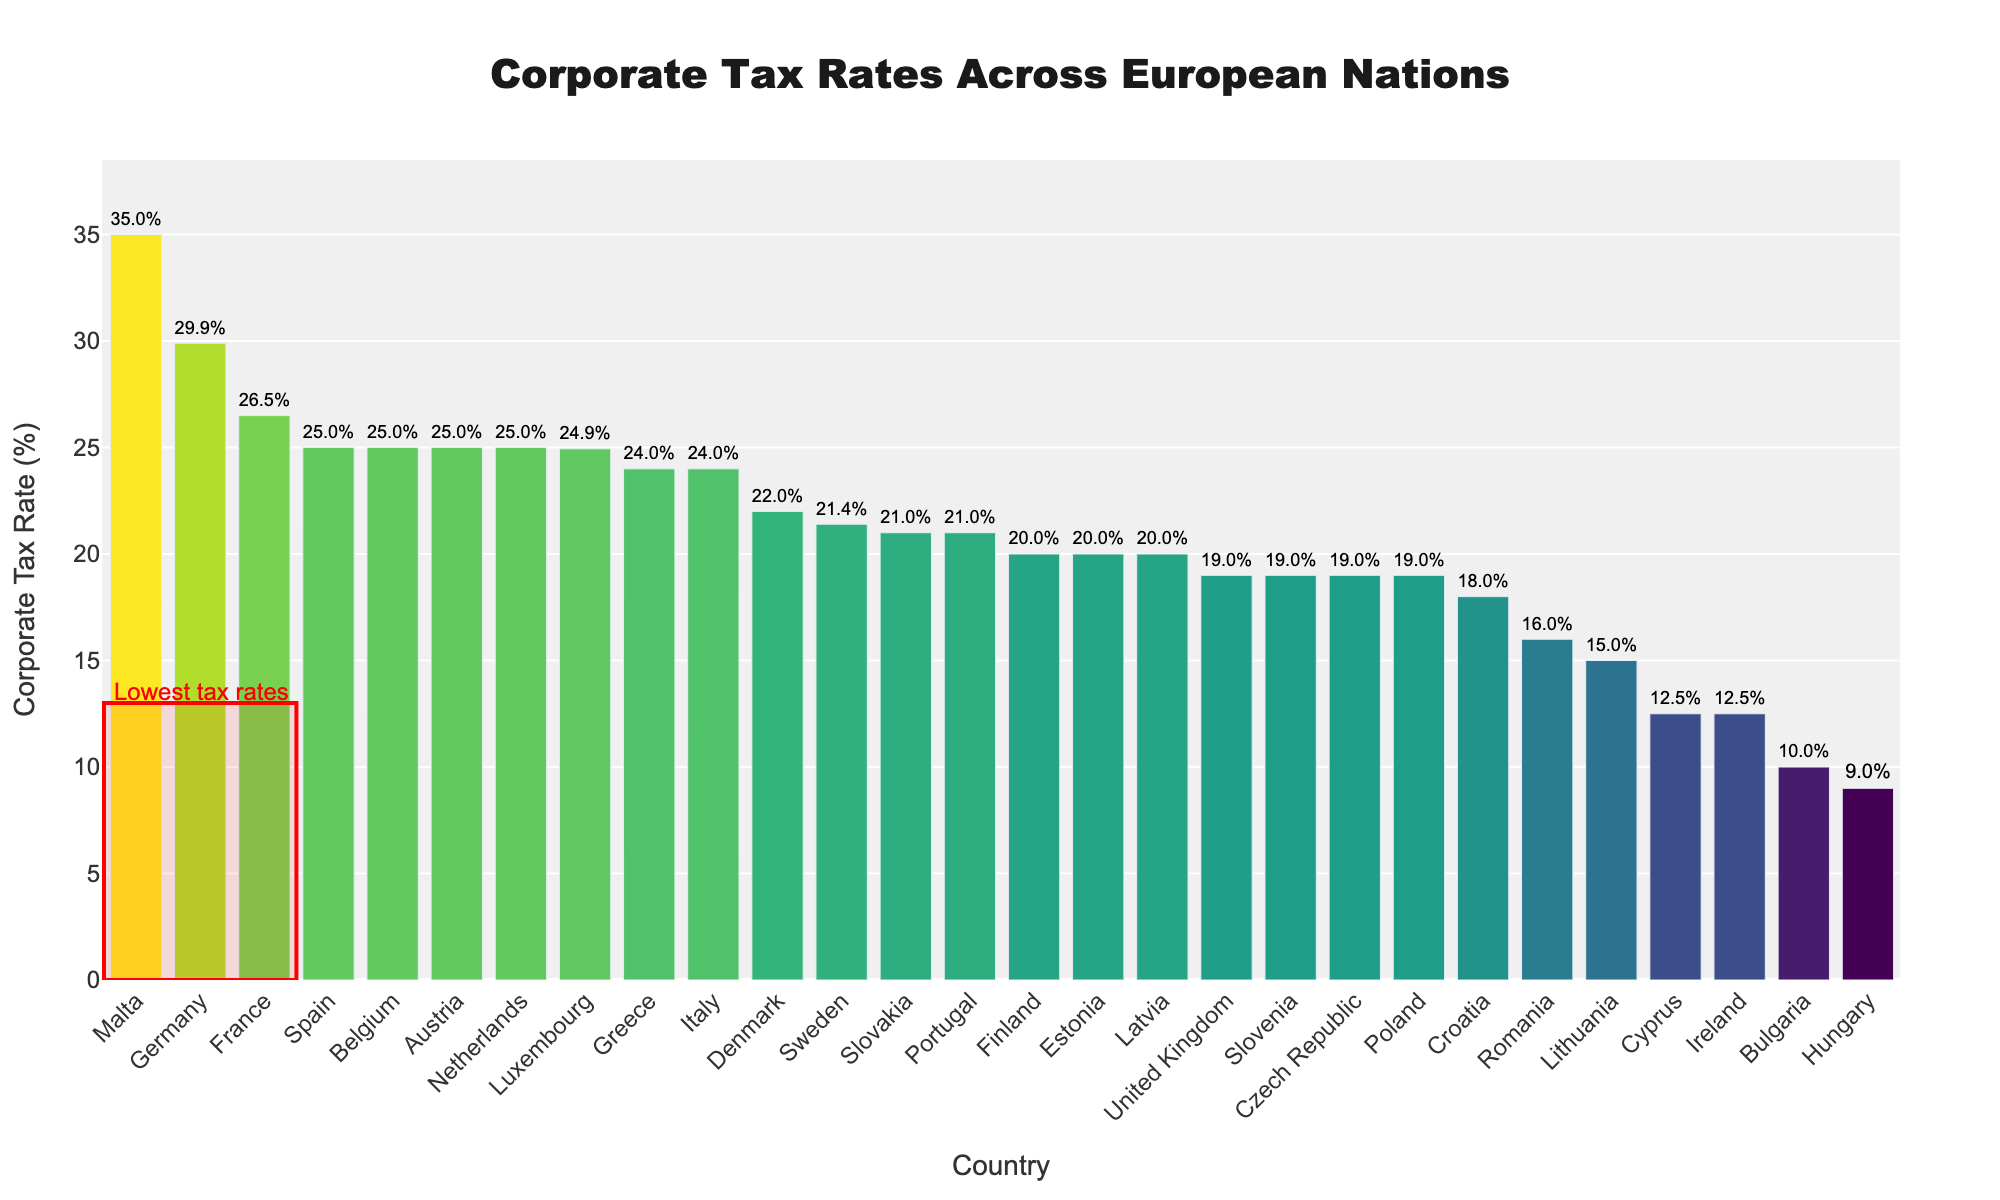Which country has the highest corporate tax rate? The highest bar in the chart represents the country with the highest tax rate. Malta has the highest corporate tax rate at 35%.
Answer: Malta Which countries have corporate tax rates below 10%? Visually identify the bars within the highlighted section labeled "Lowest tax rates". Hungary and Bulgaria have rates below 10%.
Answer: Hungary, Bulgaria What is the difference between the highest and lowest corporate tax rates? The highest tax rate is 35% (Malta), and the lowest is 9% (Hungary). The difference is calculated as 35% - 9% = 26%.
Answer: 26% How many countries have a corporate tax rate higher than 25%? Count the bars that are higher than the 25% line. Only three countries (France, Germany, Malta) have rates higher than 25%.
Answer: 3 Which country has a corporate tax rate of exactly 19%? Find the bars exactly at the 19% level and note their country labels. The countries with a 19% rate are Poland, Czech Republic, Slovenia, and United Kingdom.
Answer: Poland, Czech Republic, Slovenia, United Kingdom Is there any country with a tax rate between 20% and 21%? Check for bars falling between the 20% to 21% range. Countries like Finland, Estonia, and Slovakia have tax rates in this range.
Answer: Finland, Estonia, Slovakia What is the average corporate tax rate of the countries within the "Lowest tax rates" section? Calculate the average of the tax rates for Hungary (9%), Bulgaria (10%), and Cyprus (12.5%). (9 + 10 + 12.5) / 3 = 10.5%
Answer: 10.5% How many countries have a corporate tax rate of exactly 25%? Identify and count the bars that are exactly at the 25% mark. The countries are Netherlands, Austria, Belgium, and Spain.
Answer: 4 What's the range of corporate tax rates for countries in the Scandinavian region (Denmark, Sweden, Finland)? Identify the bars for Denmark, Sweden, and Finland and note their tax rates (22%, 21.4%, and 20% respectively). The range is from 20% to 22%.
Answer: 2% (20%-22%) What is the visual indication of the lowest tax rates on the chart? Look for any visual elements highlighting specific bars. A red rectangle shape around the first three bars highlights the lowest tax rates.
Answer: Red rectangle shape 